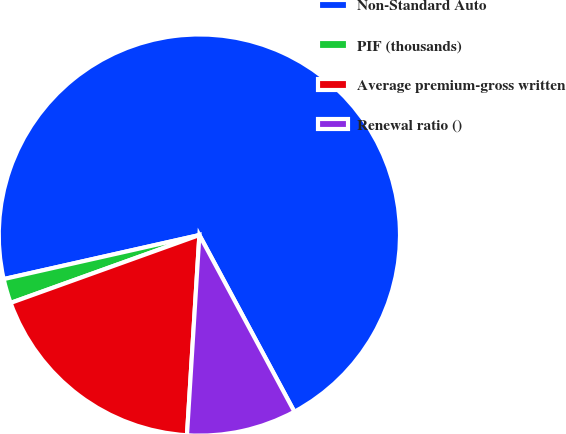Convert chart. <chart><loc_0><loc_0><loc_500><loc_500><pie_chart><fcel>Non-Standard Auto<fcel>PIF (thousands)<fcel>Average premium-gross written<fcel>Renewal ratio ()<nl><fcel>70.67%<fcel>1.97%<fcel>18.52%<fcel>8.84%<nl></chart> 